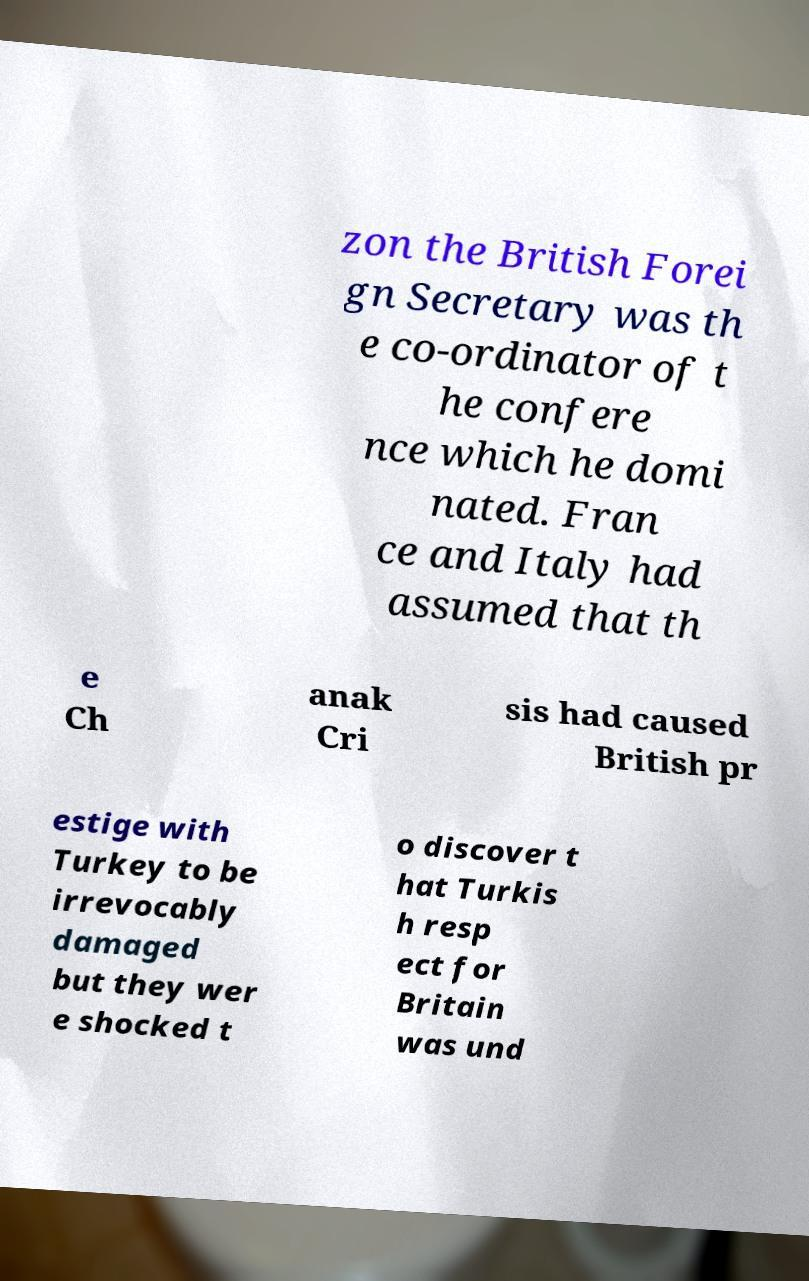Could you extract and type out the text from this image? zon the British Forei gn Secretary was th e co-ordinator of t he confere nce which he domi nated. Fran ce and Italy had assumed that th e Ch anak Cri sis had caused British pr estige with Turkey to be irrevocably damaged but they wer e shocked t o discover t hat Turkis h resp ect for Britain was und 